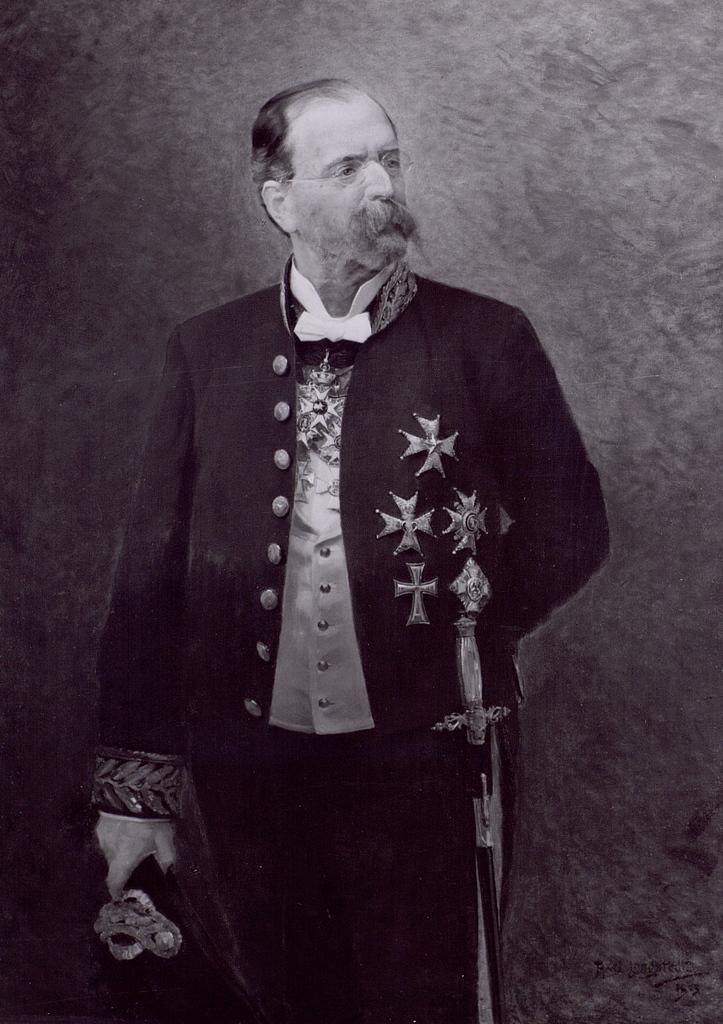Please provide a concise description of this image. In this image I can see painting of a man, I can see he is wearing specs, coat and a bow tie. I can also see a sword over here and I can see this image is black and white in colour. 